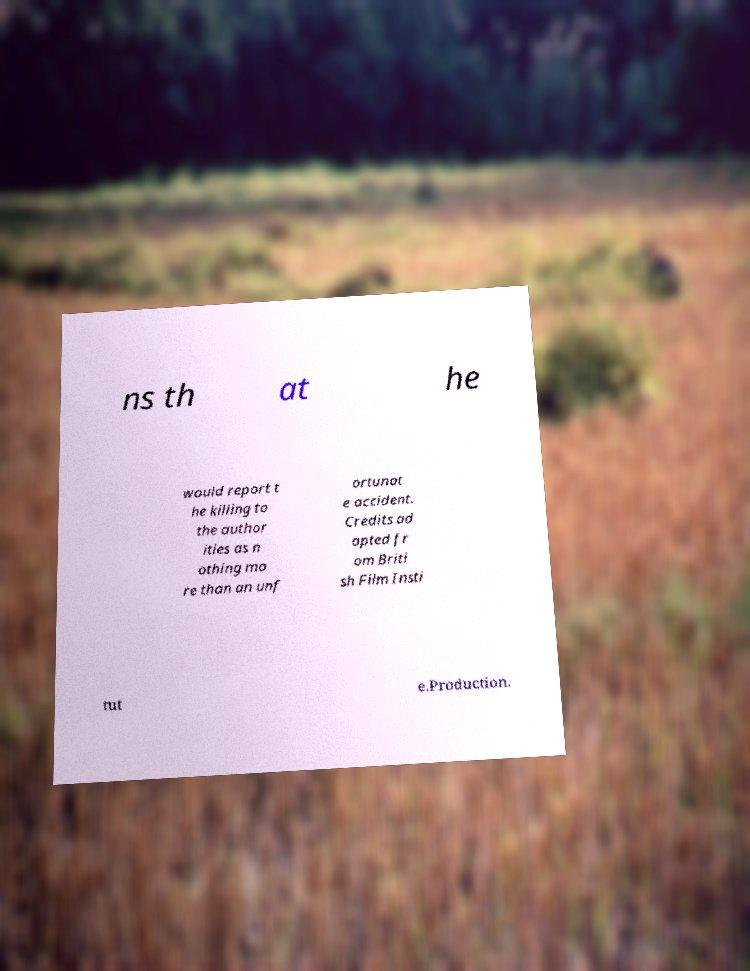Could you assist in decoding the text presented in this image and type it out clearly? ns th at he would report t he killing to the author ities as n othing mo re than an unf ortunat e accident. Credits ad apted fr om Briti sh Film Insti tut e.Production. 